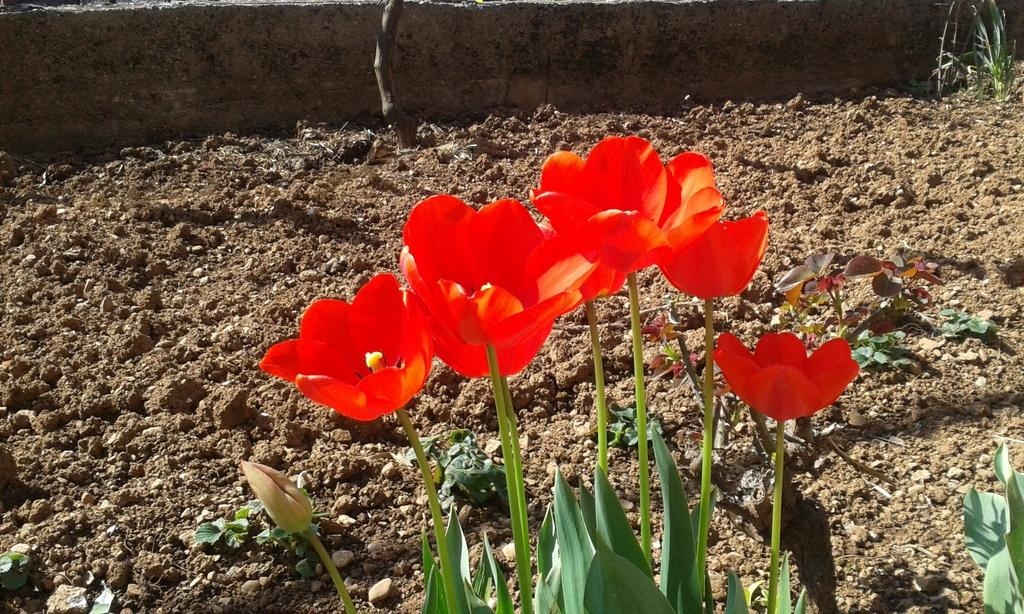What type of living organisms can be seen in the image? Plants and flowers are visible in the image. What is the texture or substance at the bottom of the image? There is mud at the bottom of the image. What can be seen in the background of the image? There is a wall in the background of the image. Where is the grandmother sitting with her scissors in the image? There is no grandmother or scissors present in the image. What type of house is visible in the image? There is no house visible in the image; it features plants, flowers, mud, and a wall. 